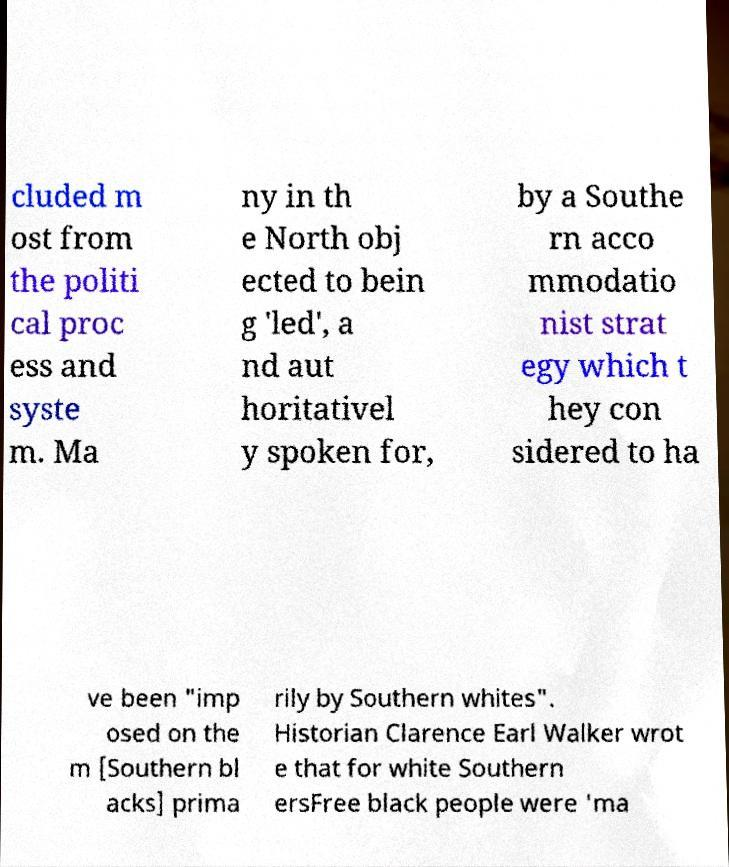Can you read and provide the text displayed in the image?This photo seems to have some interesting text. Can you extract and type it out for me? cluded m ost from the politi cal proc ess and syste m. Ma ny in th e North obj ected to bein g 'led', a nd aut horitativel y spoken for, by a Southe rn acco mmodatio nist strat egy which t hey con sidered to ha ve been "imp osed on the m [Southern bl acks] prima rily by Southern whites". Historian Clarence Earl Walker wrot e that for white Southern ersFree black people were 'ma 